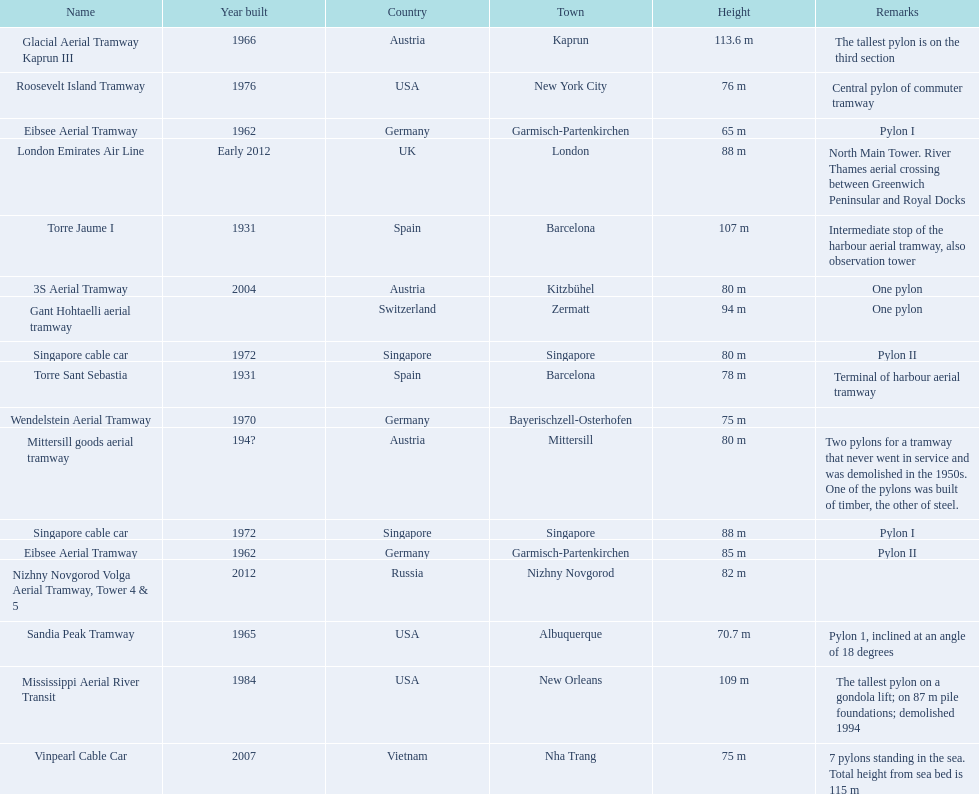Which aerial lifts are over 100 meters tall? Glacial Aerial Tramway Kaprun III, Mississippi Aerial River Transit, Torre Jaume I. Would you be able to parse every entry in this table? {'header': ['Name', 'Year built', 'Country', 'Town', 'Height', 'Remarks'], 'rows': [['Glacial Aerial Tramway Kaprun III', '1966', 'Austria', 'Kaprun', '113.6 m', 'The tallest pylon is on the third section'], ['Roosevelt Island Tramway', '1976', 'USA', 'New York City', '76 m', 'Central pylon of commuter tramway'], ['Eibsee Aerial Tramway', '1962', 'Germany', 'Garmisch-Partenkirchen', '65 m', 'Pylon I'], ['London Emirates Air Line', 'Early 2012', 'UK', 'London', '88 m', 'North Main Tower. River Thames aerial crossing between Greenwich Peninsular and Royal Docks'], ['Torre Jaume I', '1931', 'Spain', 'Barcelona', '107 m', 'Intermediate stop of the harbour aerial tramway, also observation tower'], ['3S Aerial Tramway', '2004', 'Austria', 'Kitzbühel', '80 m', 'One pylon'], ['Gant Hohtaelli aerial tramway', '', 'Switzerland', 'Zermatt', '94 m', 'One pylon'], ['Singapore cable car', '1972', 'Singapore', 'Singapore', '80 m', 'Pylon II'], ['Torre Sant Sebastia', '1931', 'Spain', 'Barcelona', '78 m', 'Terminal of harbour aerial tramway'], ['Wendelstein Aerial Tramway', '1970', 'Germany', 'Bayerischzell-Osterhofen', '75 m', ''], ['Mittersill goods aerial tramway', '194?', 'Austria', 'Mittersill', '80 m', 'Two pylons for a tramway that never went in service and was demolished in the 1950s. One of the pylons was built of timber, the other of steel.'], ['Singapore cable car', '1972', 'Singapore', 'Singapore', '88 m', 'Pylon I'], ['Eibsee Aerial Tramway', '1962', 'Germany', 'Garmisch-Partenkirchen', '85 m', 'Pylon II'], ['Nizhny Novgorod Volga Aerial Tramway, Tower 4 & 5', '2012', 'Russia', 'Nizhny Novgorod', '82 m', ''], ['Sandia Peak Tramway', '1965', 'USA', 'Albuquerque', '70.7 m', 'Pylon 1, inclined at an angle of 18 degrees'], ['Mississippi Aerial River Transit', '1984', 'USA', 'New Orleans', '109 m', 'The tallest pylon on a gondola lift; on 87 m pile foundations; demolished 1994'], ['Vinpearl Cable Car', '2007', 'Vietnam', 'Nha Trang', '75 m', '7 pylons standing in the sea. Total height from sea bed is 115 m']]} Which of those was built last? Mississippi Aerial River Transit. And what is its total height? 109 m. 